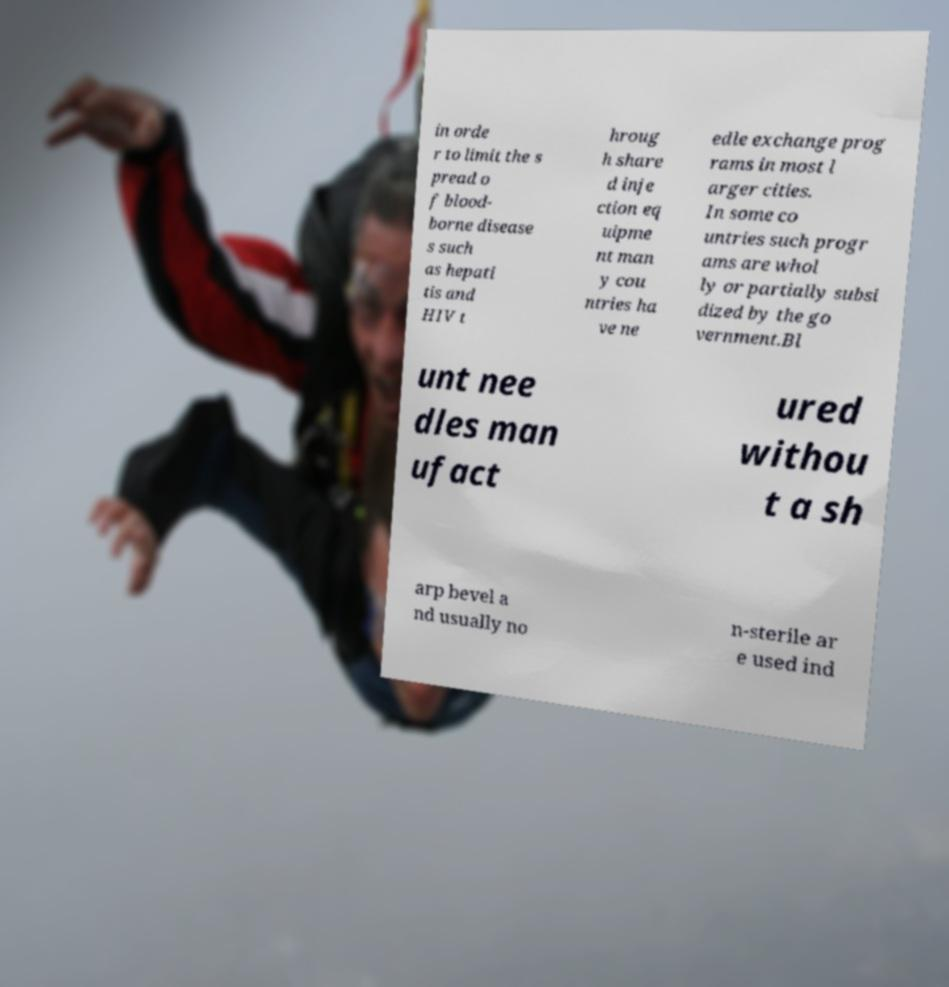Can you read and provide the text displayed in the image?This photo seems to have some interesting text. Can you extract and type it out for me? in orde r to limit the s pread o f blood- borne disease s such as hepati tis and HIV t hroug h share d inje ction eq uipme nt man y cou ntries ha ve ne edle exchange prog rams in most l arger cities. In some co untries such progr ams are whol ly or partially subsi dized by the go vernment.Bl unt nee dles man ufact ured withou t a sh arp bevel a nd usually no n-sterile ar e used ind 